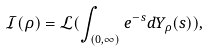<formula> <loc_0><loc_0><loc_500><loc_500>\mathcal { I } ( \rho ) = \mathcal { L } ( \int _ { ( 0 , \infty ) } e ^ { - s } d Y _ { \rho } ( s ) ) ,</formula> 